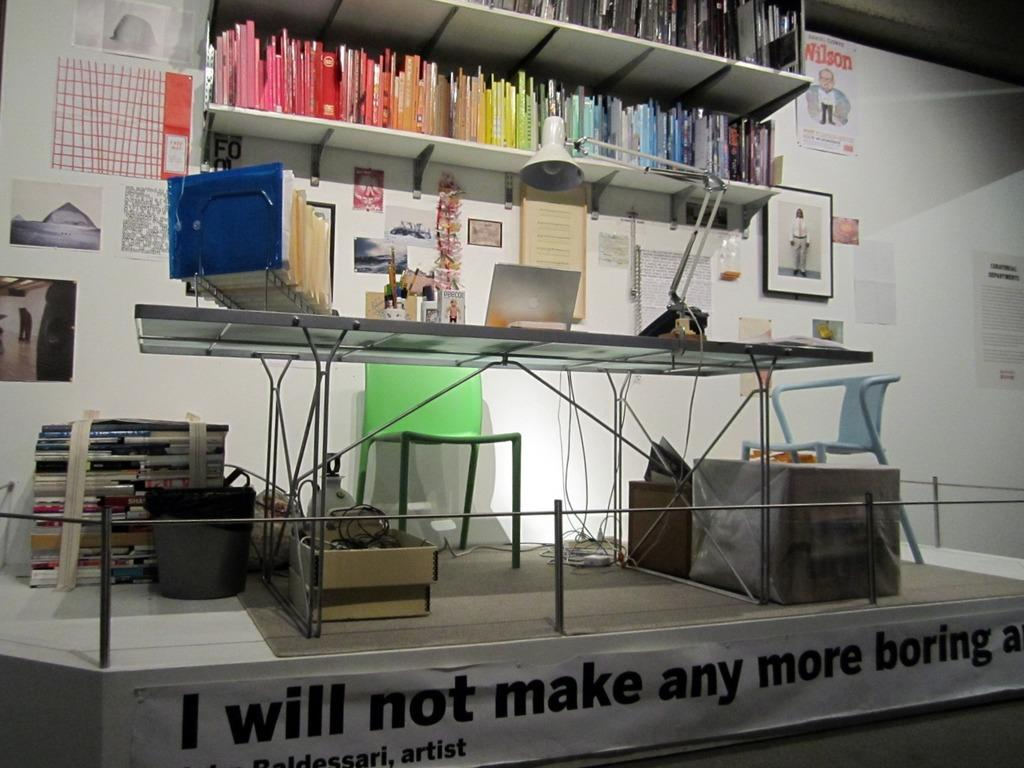<image>
Describe the image concisely. The banner attached to the work space states "I will not make any more boring art". 